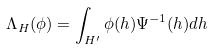<formula> <loc_0><loc_0><loc_500><loc_500>\Lambda _ { H } ( \phi ) = \int _ { H ^ { \prime } } \phi ( h ) \Psi ^ { - 1 } ( h ) d h</formula> 